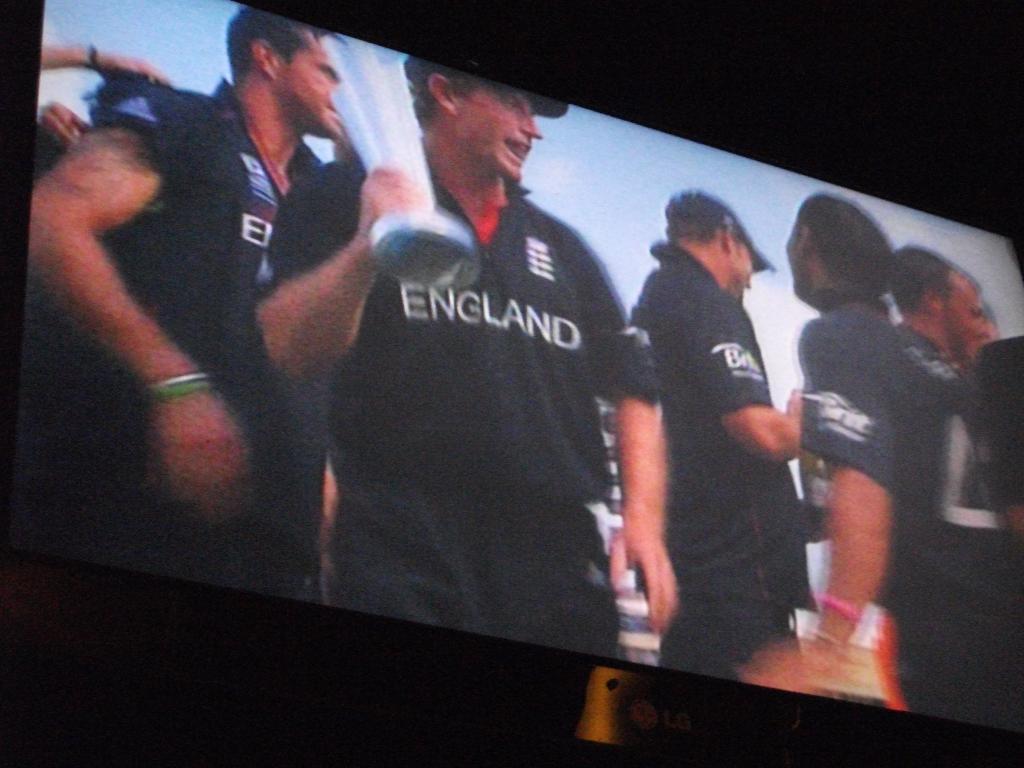What country is written on the man's shirt who is holding a trophy?
Your response must be concise. England. 